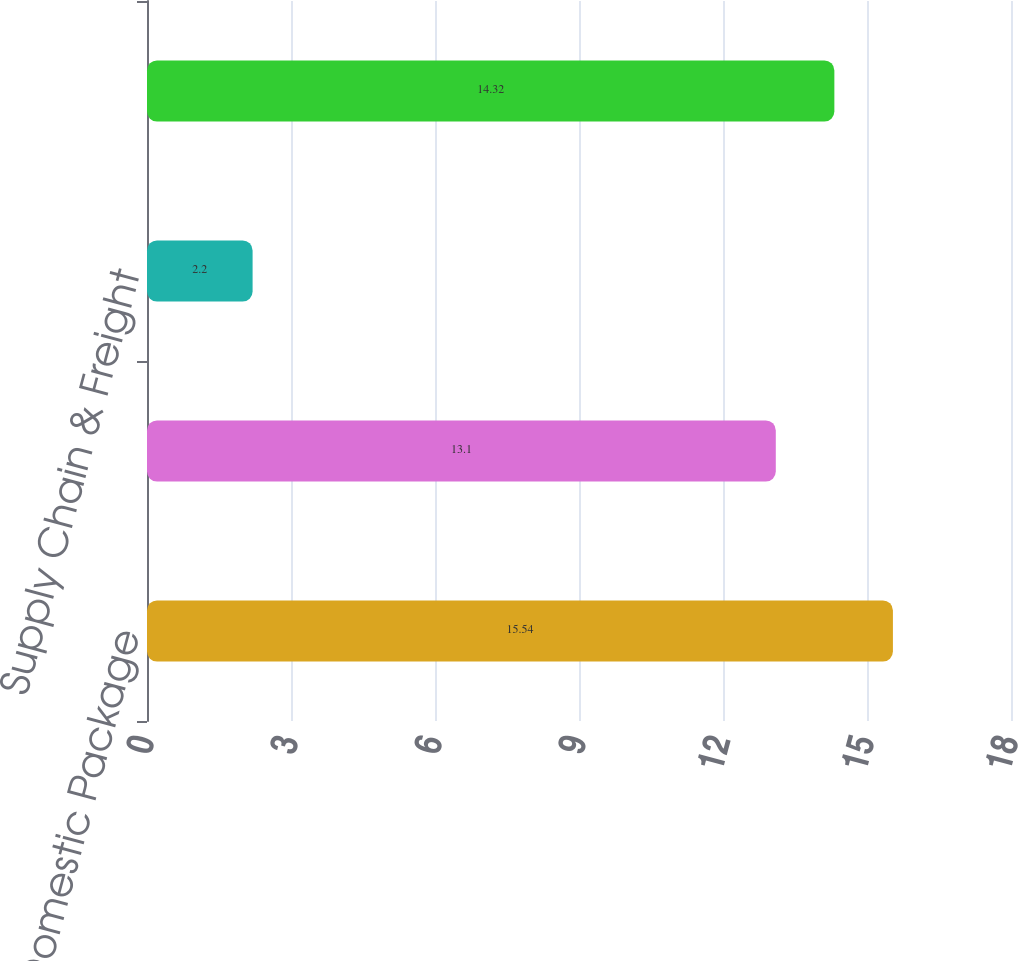Convert chart to OTSL. <chart><loc_0><loc_0><loc_500><loc_500><bar_chart><fcel>US Domestic Package<fcel>International Package<fcel>Supply Chain & Freight<fcel>Consolidated Operating Margin<nl><fcel>15.54<fcel>13.1<fcel>2.2<fcel>14.32<nl></chart> 